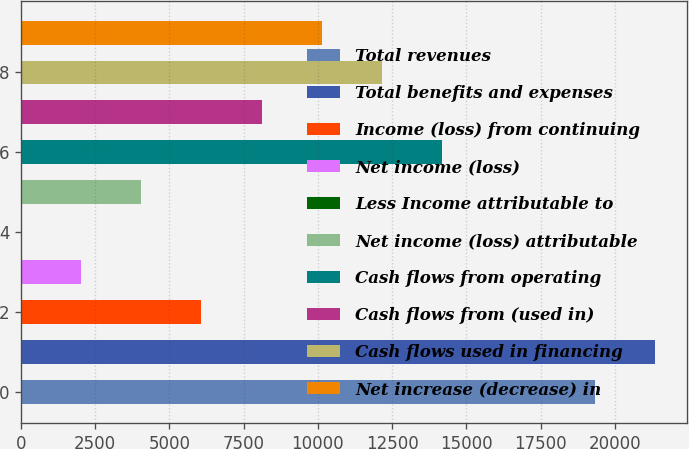Convert chart. <chart><loc_0><loc_0><loc_500><loc_500><bar_chart><fcel>Total revenues<fcel>Total benefits and expenses<fcel>Income (loss) from continuing<fcel>Net income (loss)<fcel>Less Income attributable to<fcel>Net income (loss) attributable<fcel>Cash flows from operating<fcel>Cash flows from (used in)<fcel>Cash flows used in financing<fcel>Net increase (decrease) in<nl><fcel>19337<fcel>21361.9<fcel>6076.7<fcel>2026.9<fcel>2<fcel>4051.8<fcel>14176.3<fcel>8101.6<fcel>12151.4<fcel>10126.5<nl></chart> 